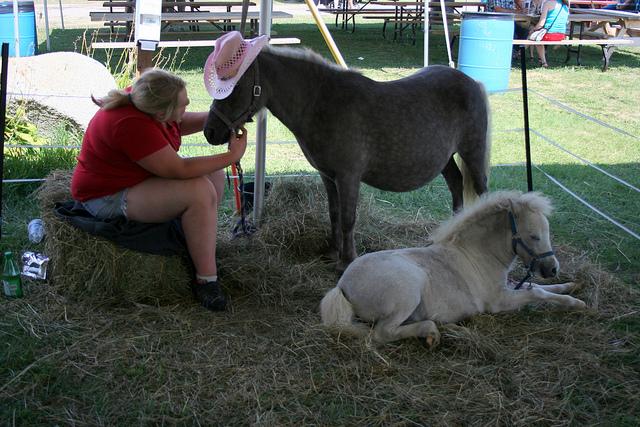What is the girl sitting on?
Be succinct. Hay. Is one of the horses wearing a hat?
Short answer required. Yes. What kind of animals are shown?
Give a very brief answer. Ponies. 